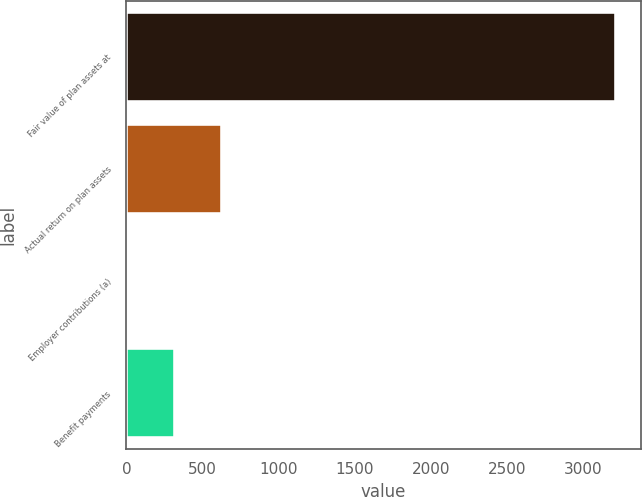<chart> <loc_0><loc_0><loc_500><loc_500><bar_chart><fcel>Fair value of plan assets at<fcel>Actual return on plan assets<fcel>Employer contributions (a)<fcel>Benefit payments<nl><fcel>3218.4<fcel>628.8<fcel>6<fcel>317.4<nl></chart> 